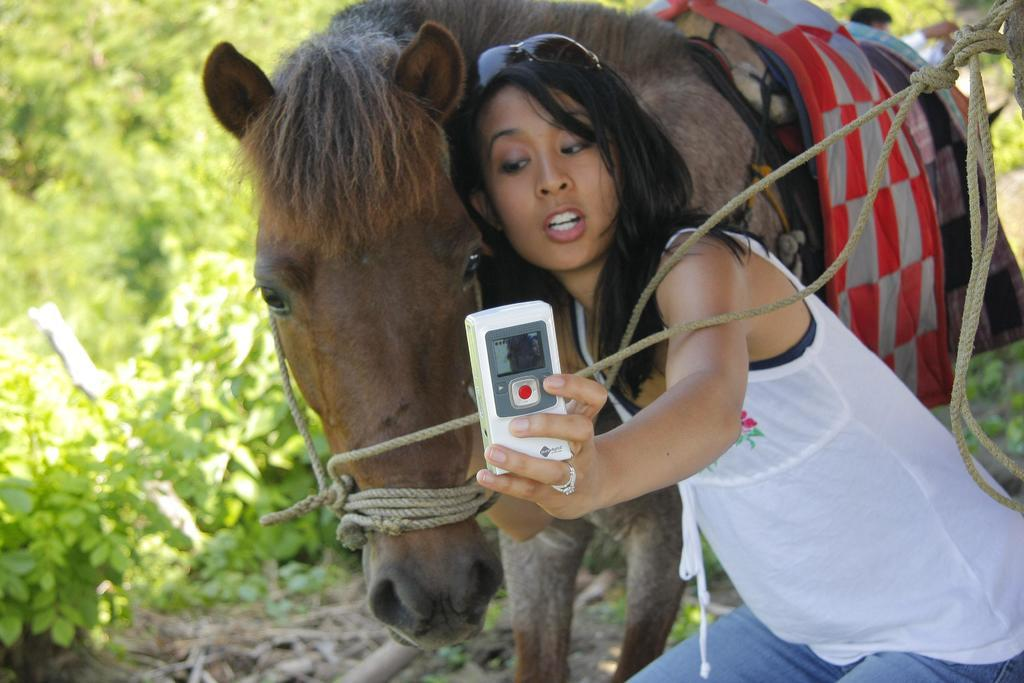Who is the main subject in the image? There is a woman in the image. What is the woman doing in the image? The woman is taking a selfie. What other animal is present in the image? There is a horse in the image. What color is the woman's top? The woman is wearing a white top. What accessories is the woman wearing? The woman is wearing glasses. What can be observed about the background of the image? The background of the image is very green and likely represents greenery. What mathematical operation is the woman performing in the image? There is no indication in the image that the woman is performing any mathematical operation. 